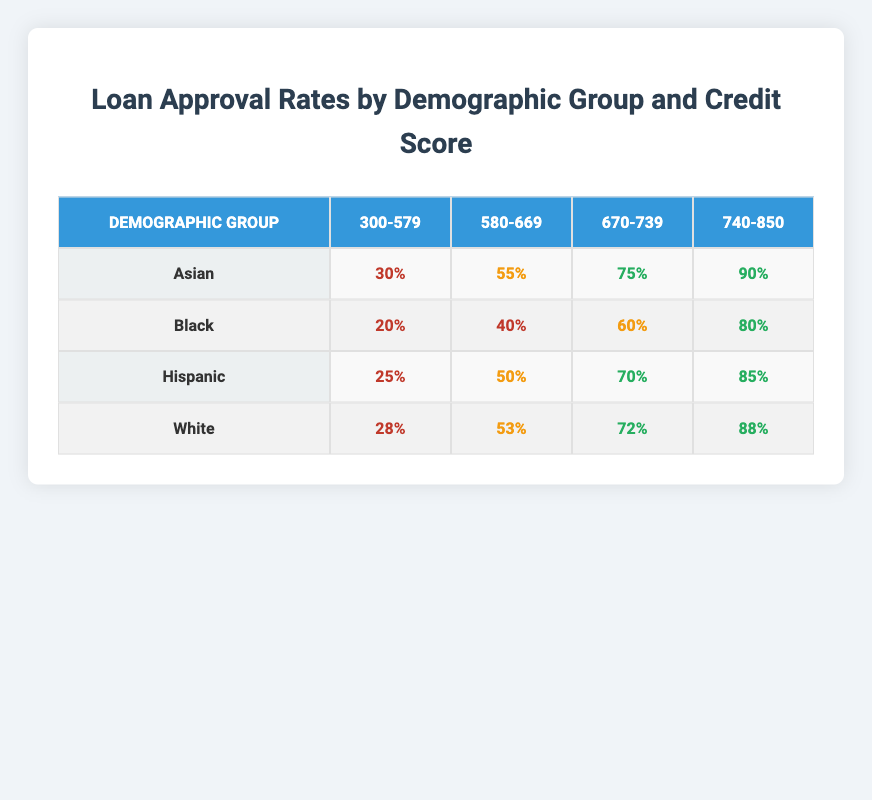What is the loan approval rate for Black individuals with a credit score of 300-579? According to the table, the loan approval rate for Black individuals in the credit score range of 300-579 is listed as 20%.
Answer: 20% What is the highest approval rate for the Hispanic demographic group? The table indicates that the highest loan approval rate for the Hispanic group occurs in the credit score range of 740-850, where it is 85%.
Answer: 85% Which demographic group has the lowest approval rate in the credit score range of 580-669? Looking at the table, the Black demographic group shows the lowest approval rate of 40% in the credit score range of 580-669 compared to other groups.
Answer: Black What is the average loan approval rate for the White demographic across all credit score ranges? The approval rates for White individuals are: 28% (300-579), 53% (580-669), 72% (670-739), and 88% (740-850). Adding these values gives 28 + 53 + 72 + 88 = 241, and dividing by 4, the average is 241 / 4 = 60.25%.
Answer: 60.25% Is the approval rate for Asians with a credit score of 670-739 higher than the approval rate for Hispanics in the same credit score range? Yes, the approval rate for Asians with a credit score of 670-739 is 75%, while for Hispanics it is 70%. Thus, it is indeed higher.
Answer: Yes What proportion of the Black demographic has an approval rate of at least 60%? Among the credit score ranges for Black individuals, those with scores of 670-739 (60%) and 740-850 (80%) have approval rates of at least 60%. Therefore, 2 out of 4 ranges meet this criterion, giving a proportion of 2/4 = 0.5 or 50%.
Answer: 50% What is the difference in approval rates between the highest and lowest approval rates for the Asian demographic group across credit score ranges? The highest approval rate for Asians is 90% (740-850) and the lowest is 30% (300-579). The difference is 90% - 30% = 60%.
Answer: 60% Are the loan approval rates for individuals with a credit score of 740-850 across all demographic groups above 80%? Yes, the approval rates for the credit score range of 740-850 are: Asian (90%), Black (80%), Hispanic (85%), and White (88%). All are above 80%.
Answer: Yes 